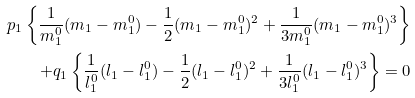<formula> <loc_0><loc_0><loc_500><loc_500>p _ { 1 } \left \{ \frac { 1 } { m _ { 1 } ^ { 0 } } ( m _ { 1 } - m _ { 1 } ^ { 0 } ) - \frac { 1 } { 2 } ( m _ { 1 } - m _ { 1 } ^ { 0 } ) ^ { 2 } + \frac { 1 } { 3 m _ { 1 } ^ { 0 } } ( m _ { 1 } - m _ { 1 } ^ { 0 } ) ^ { 3 } \right \} \\ + q _ { 1 } \left \{ \frac { 1 } { l _ { 1 } ^ { 0 } } ( l _ { 1 } - l _ { 1 } ^ { 0 } ) - \frac { 1 } { 2 } ( l _ { 1 } - l _ { 1 } ^ { 0 } ) ^ { 2 } + \frac { 1 } { 3 l _ { 1 } ^ { 0 } } ( l _ { 1 } - l _ { 1 } ^ { 0 } ) ^ { 3 } \right \} = 0</formula> 